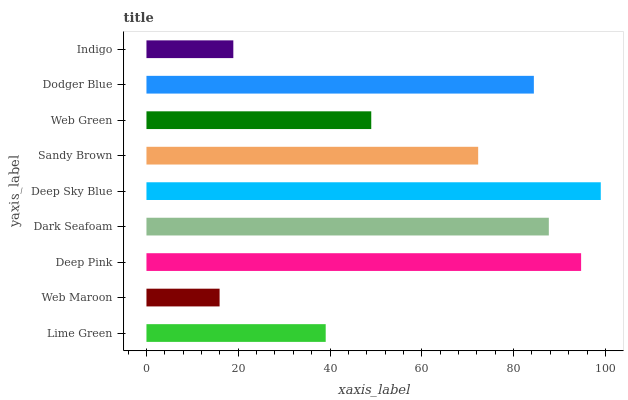Is Web Maroon the minimum?
Answer yes or no. Yes. Is Deep Sky Blue the maximum?
Answer yes or no. Yes. Is Deep Pink the minimum?
Answer yes or no. No. Is Deep Pink the maximum?
Answer yes or no. No. Is Deep Pink greater than Web Maroon?
Answer yes or no. Yes. Is Web Maroon less than Deep Pink?
Answer yes or no. Yes. Is Web Maroon greater than Deep Pink?
Answer yes or no. No. Is Deep Pink less than Web Maroon?
Answer yes or no. No. Is Sandy Brown the high median?
Answer yes or no. Yes. Is Sandy Brown the low median?
Answer yes or no. Yes. Is Web Green the high median?
Answer yes or no. No. Is Dodger Blue the low median?
Answer yes or no. No. 